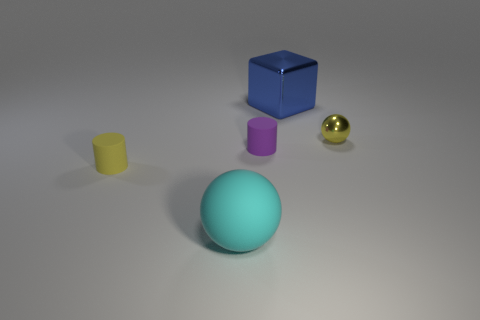What shape is the tiny shiny thing that is right of the rubber cylinder on the right side of the big object in front of the small yellow sphere?
Provide a succinct answer. Sphere. How many things are tiny matte cylinders that are to the right of the yellow cylinder or things that are to the right of the yellow cylinder?
Your response must be concise. 4. Do the yellow matte thing and the cyan matte thing on the left side of the yellow metal object have the same size?
Keep it short and to the point. No. Does the large thing that is to the left of the big blue thing have the same material as the yellow object in front of the yellow metallic object?
Your answer should be very brief. Yes. Is the number of things on the right side of the blue cube the same as the number of large cyan matte balls behind the big rubber ball?
Offer a very short reply. No. How many shiny cubes have the same color as the tiny shiny sphere?
Offer a terse response. 0. There is a tiny cylinder that is the same color as the tiny metal sphere; what is its material?
Offer a very short reply. Rubber. What number of metallic objects are either tiny brown cylinders or cyan things?
Your response must be concise. 0. There is a small object that is right of the big blue object; is it the same shape as the small matte thing to the left of the cyan rubber ball?
Your answer should be compact. No. What number of rubber things are right of the big blue shiny object?
Keep it short and to the point. 0. 